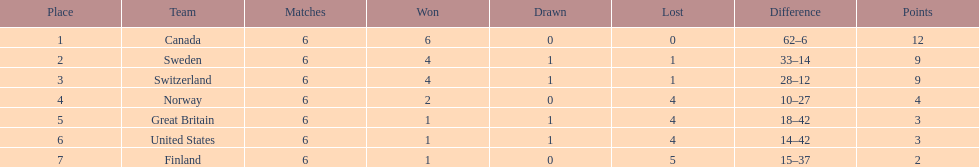How many teams had merely 1 success? 3. 